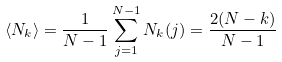Convert formula to latex. <formula><loc_0><loc_0><loc_500><loc_500>\langle N _ { k } \rangle = \frac { 1 } { N - 1 } \sum _ { j = 1 } ^ { N - 1 } N _ { k } ( j ) = \frac { 2 ( N - k ) } { N - 1 }</formula> 